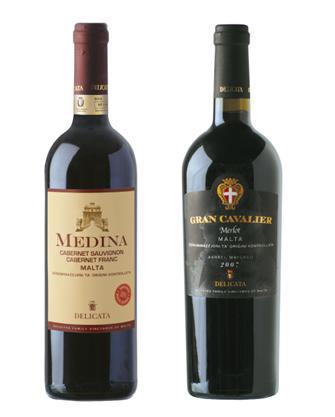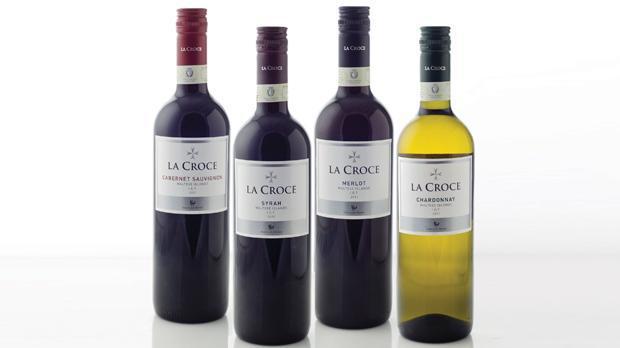The first image is the image on the left, the second image is the image on the right. Examine the images to the left and right. Is the description "Exactly six bottles of wine are capped and have labels, and are divided into two groups, at least two bottles in each group." accurate? Answer yes or no. Yes. The first image is the image on the left, the second image is the image on the right. Considering the images on both sides, is "There are no more than three wine bottles in the left image." valid? Answer yes or no. Yes. 